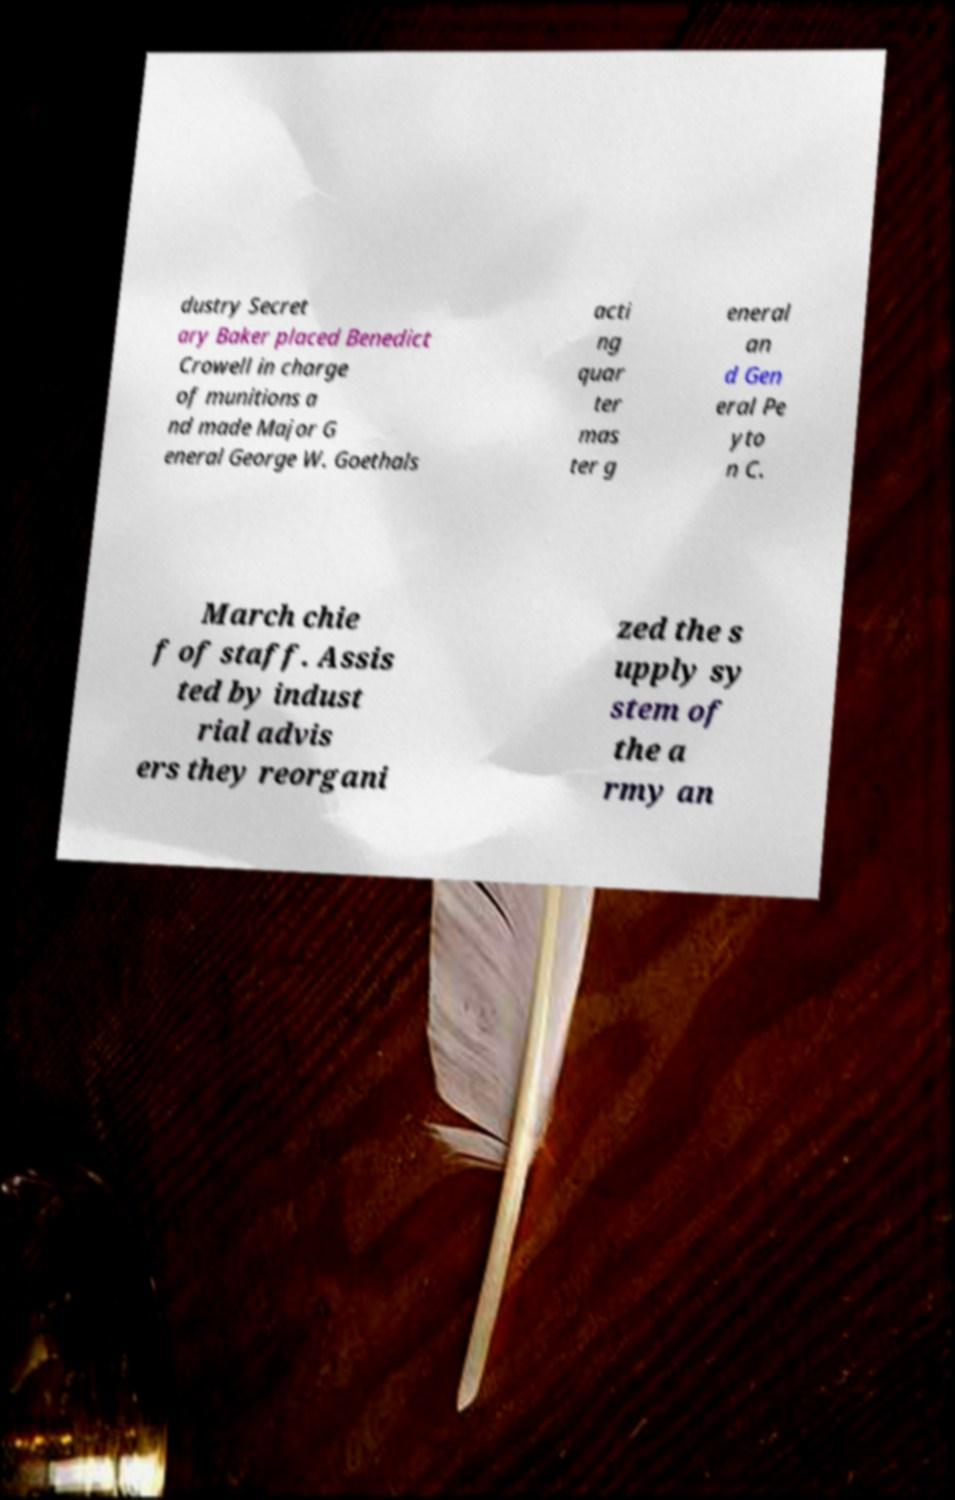Please identify and transcribe the text found in this image. dustry Secret ary Baker placed Benedict Crowell in charge of munitions a nd made Major G eneral George W. Goethals acti ng quar ter mas ter g eneral an d Gen eral Pe yto n C. March chie f of staff. Assis ted by indust rial advis ers they reorgani zed the s upply sy stem of the a rmy an 